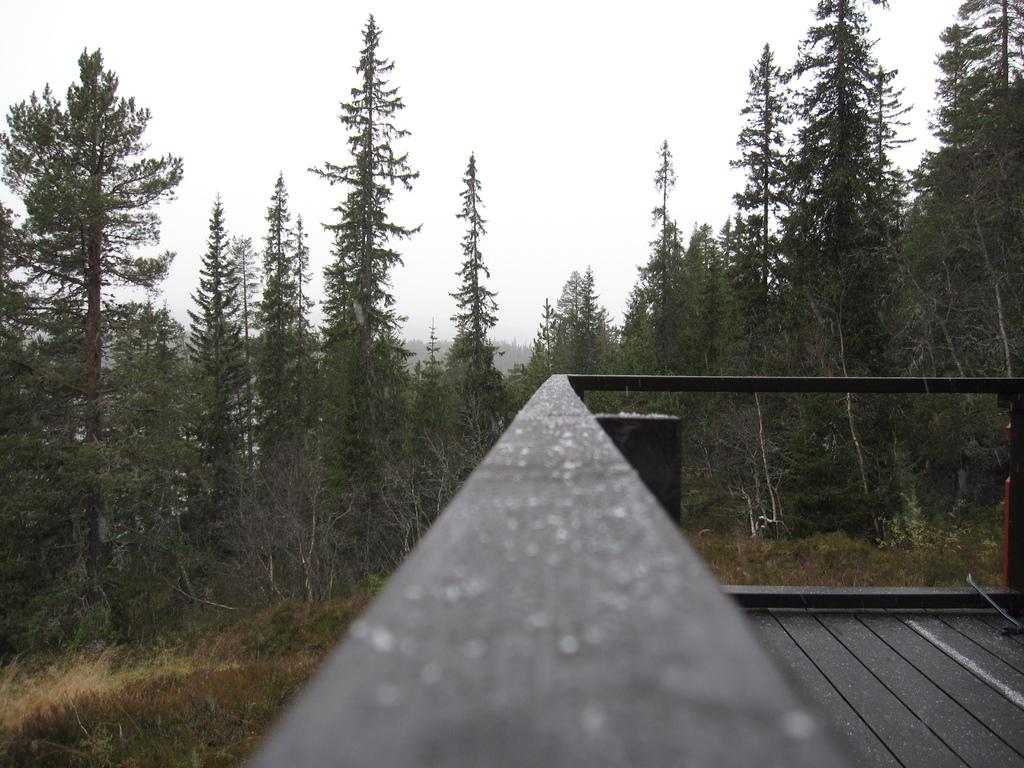What can be seen on the right side of the image? There is a balcony on the right side of the image. What type of vegetation is visible in the background of the image? Trees are present on the land in the background of the image. What is visible above the land in the image? The sky is visible above the land. How many plates are on the balcony in the image? There is no mention of plates in the image, so it is not possible to determine their presence or quantity. 